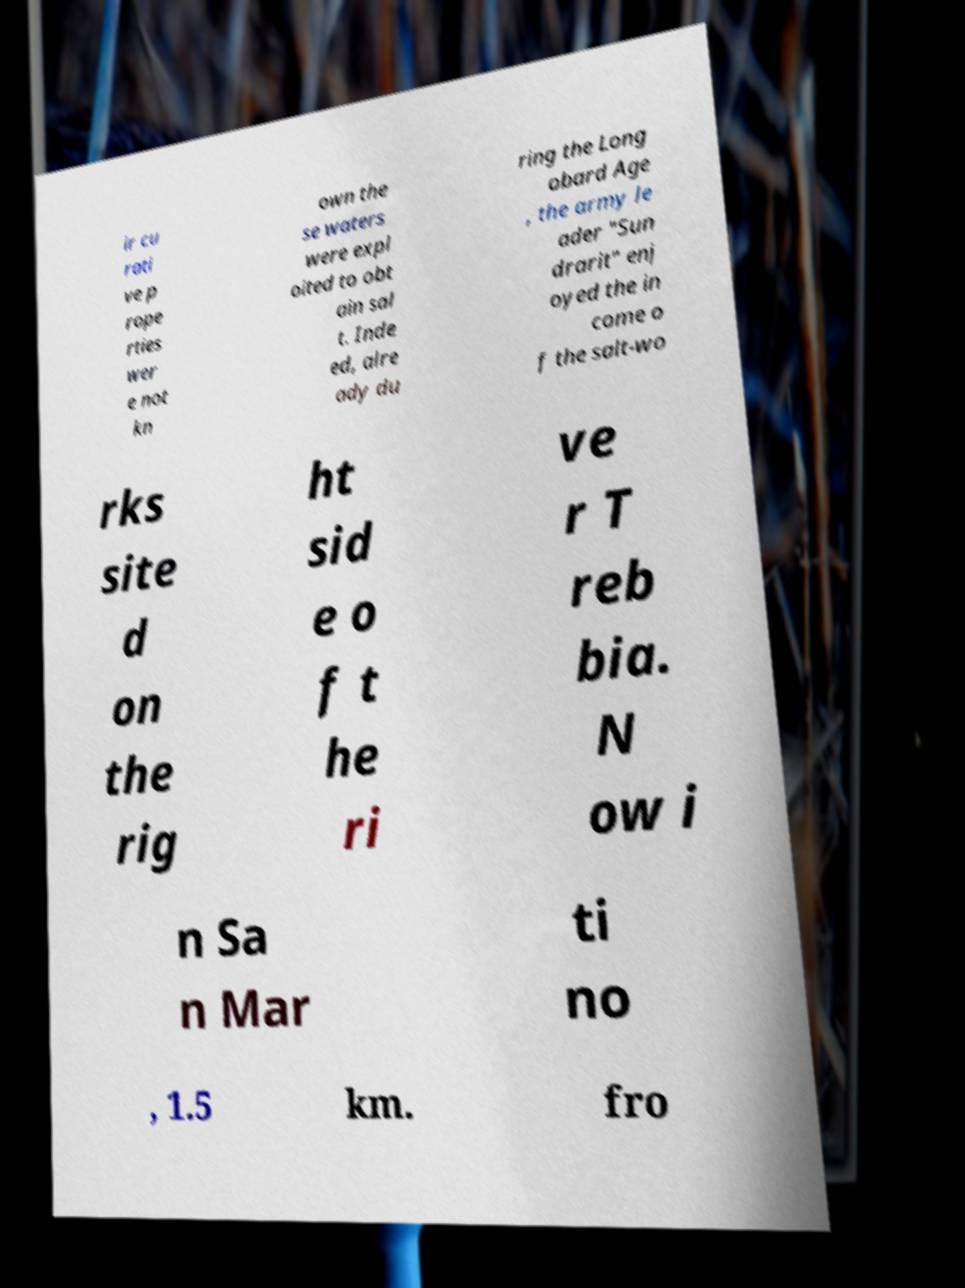Could you assist in decoding the text presented in this image and type it out clearly? ir cu rati ve p rope rties wer e not kn own the se waters were expl oited to obt ain sal t. Inde ed, alre ady du ring the Long obard Age , the army le ader "Sun drarit" enj oyed the in come o f the salt-wo rks site d on the rig ht sid e o f t he ri ve r T reb bia. N ow i n Sa n Mar ti no , 1.5 km. fro 